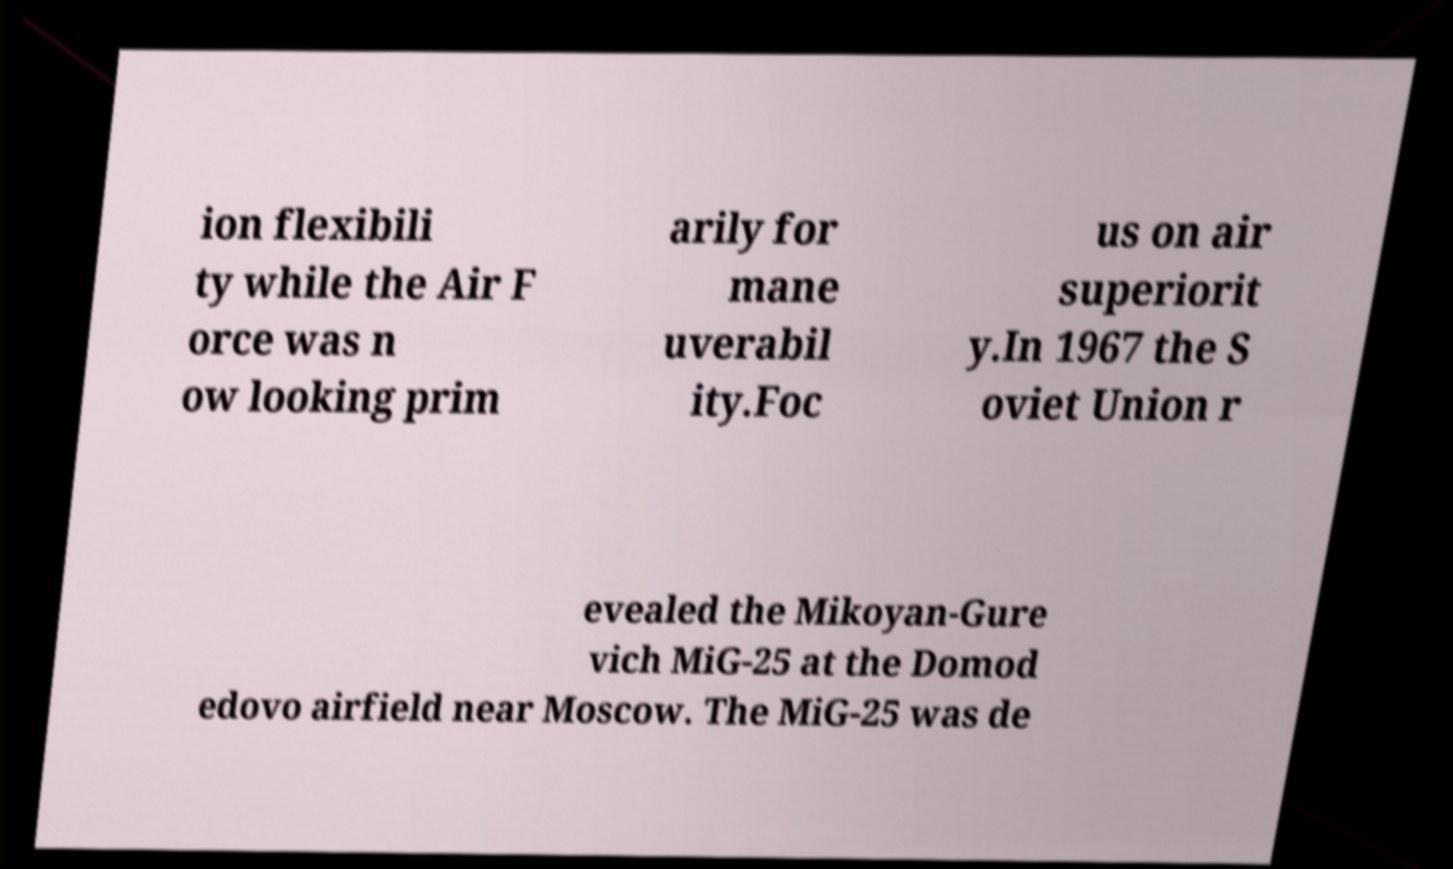Could you extract and type out the text from this image? ion flexibili ty while the Air F orce was n ow looking prim arily for mane uverabil ity.Foc us on air superiorit y.In 1967 the S oviet Union r evealed the Mikoyan-Gure vich MiG-25 at the Domod edovo airfield near Moscow. The MiG-25 was de 